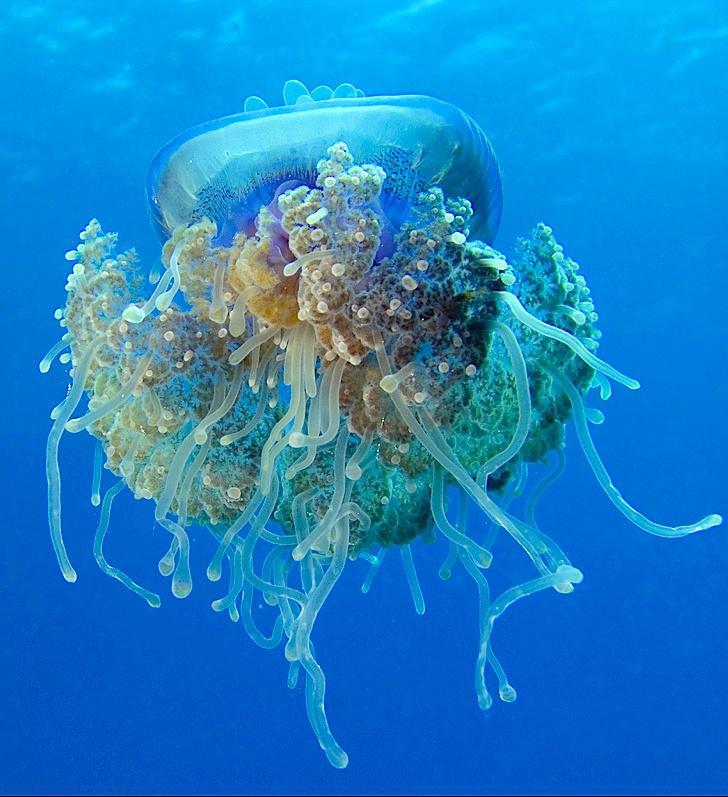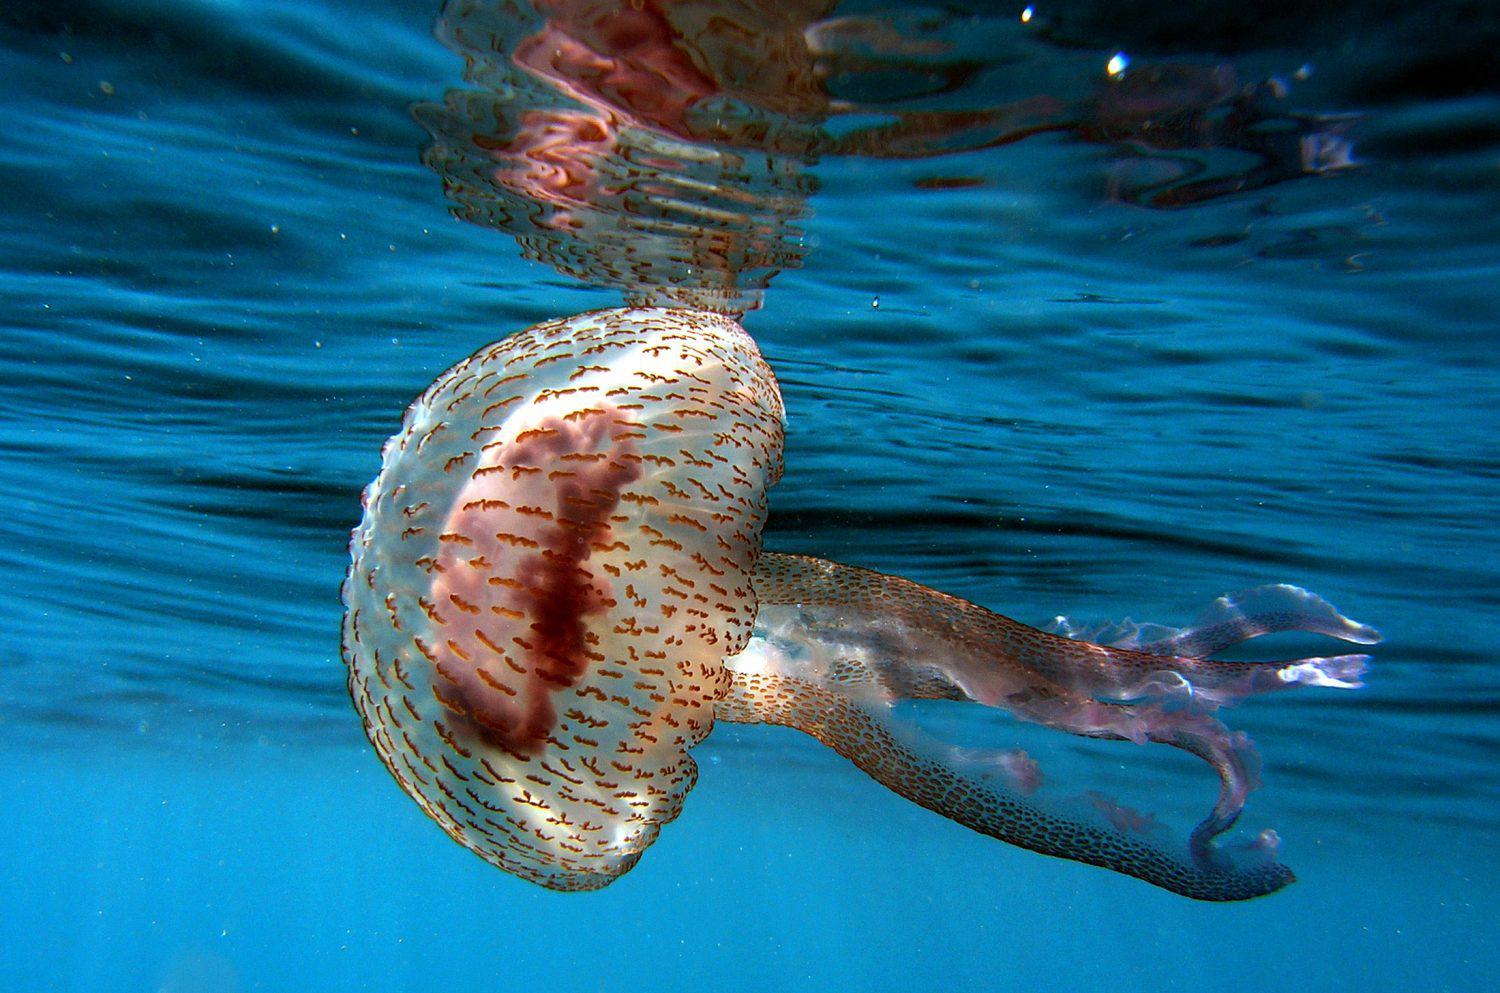The first image is the image on the left, the second image is the image on the right. Considering the images on both sides, is "There are at least two small fish swimming near the jellyfish in one of the images." valid? Answer yes or no. No. 